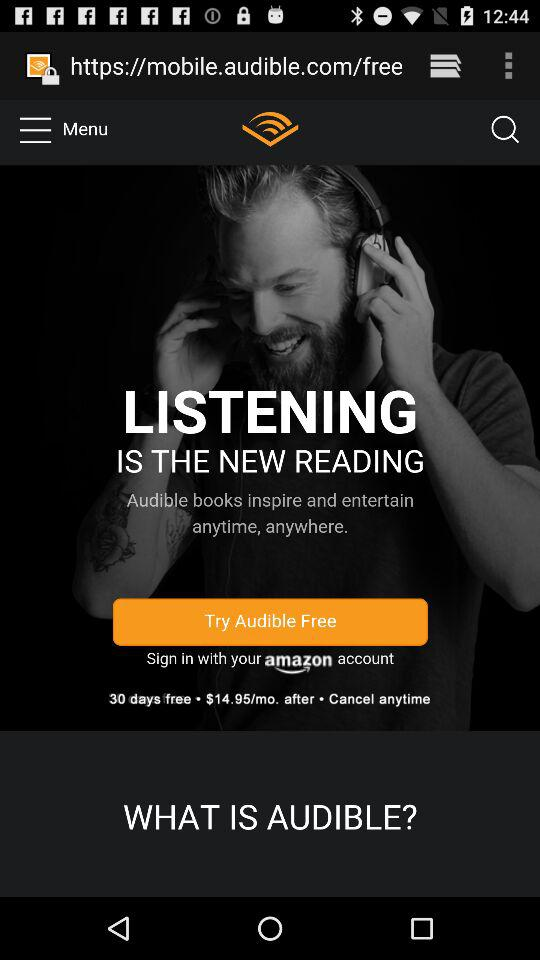What is the monthly subscription price? The monthly subscription price is $14.95. 